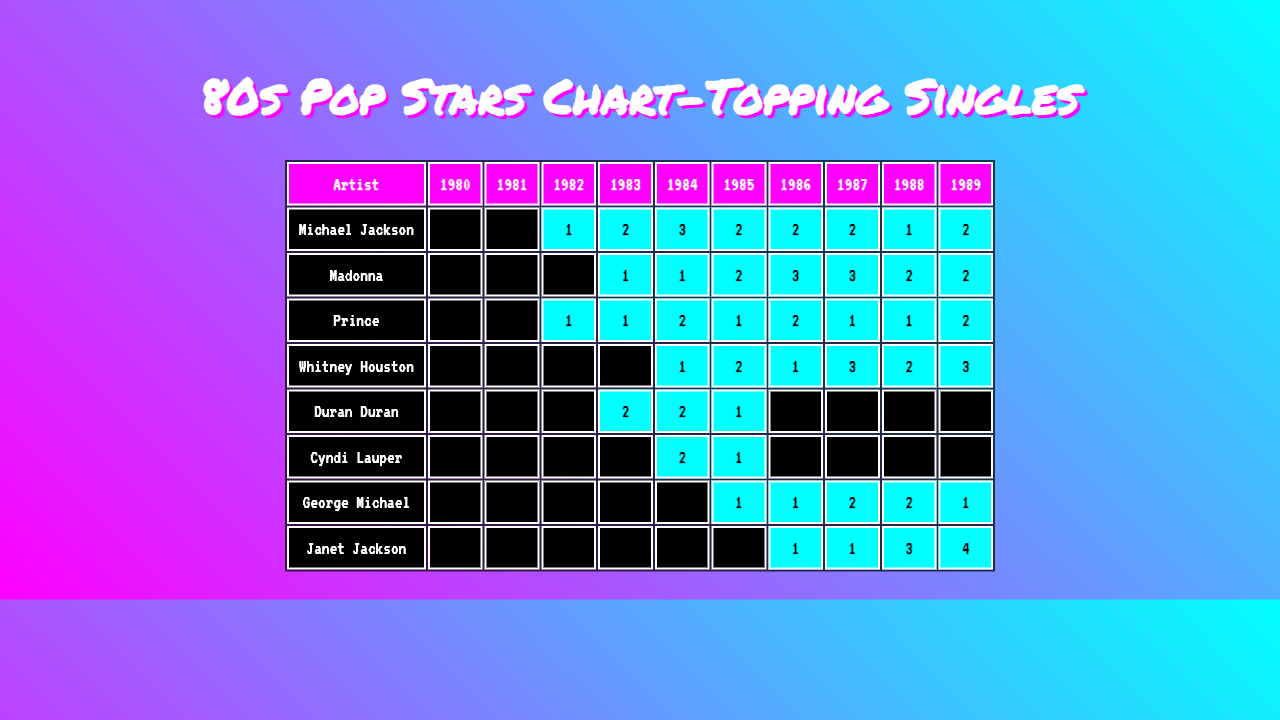What artist had the most chart-topping singles in 1984? Looking at the column for the year 1984, Michael Jackson has 3 chart-topping singles, which is the highest number among all artists for that year.
Answer: Michael Jackson How many chart-topping singles did Prince have in total during the 80s? Adding up Prince's singles from all years: 1 + 1 + 2 + 1 + 1 + 2 = 8.
Answer: 8 Did Whitney Houston reach the top of the charts in 1981? In the column for 1981, Whitney Houston has 0 chart-topping singles, indicating she did not reach the top that year.
Answer: No Which artist had the highest total of chart-topping singles in 1987, and how many did they have? Looking at the 1987 column, Janet Jackson has 1, Michael Jackson has 2, Whitney Houston has 3, and others have equal or fewer. Whitney Houston had the highest at 3.
Answer: Whitney Houston, 3 What is the average number of chart-topping singles per year for Cyndi Lauper over the decade? Summing Cyndi Lauper's singles: 0 + 0 + 0 + 0 + 2 + 1 + 0 + 0 + 0 = 3. Then, dividing by the number of years (10): 3 / 10 = 0.3.
Answer: 0.3 In which year did George Michael achieve the most chart-topping singles, and how many were there? Checking George Michael's row, he had 2 singles in both 1987 and 1988, which are the highest amounts for his row.
Answer: 1987 and 1988, 2 singles What was the trend of Duran Duran’s chart-topping singles throughout the 80s? Analyzing the numbers: 0, 0, 0, 2, 2, 1, 0, 0, 0, 0 shows they peaked in 1983 and 1984 with 2 each, but then decreased to 0 again afterward.
Answer: Peaked in 1983 and 1984, then decreased to 0 Which artist had a steady increase in chart-topping singles from 1982 to 1986? Examining the years for each artist, George Michael had 0 in 1982, 1 in 1985, and 2 in 1986. This shows an increase year by year.
Answer: George Michael How many artists had chart-topping singles in 1985, and who were they? In 1985, looking at the table, Michael Jackson (2), Madonna (2), Whitney Houston (2), and Cyndi Lauper (1) had singles. Four artists made the charts that year.
Answer: Four artists: Michael Jackson, Madonna, Whitney Houston, Cyndi Lauper What is the difference in chart-topping singles between Michael Jackson and Janet Jackson in 1988? For 1988, Michael Jackson had 1 and Janet Jackson had 3. The difference is 3 - 1 = 2.
Answer: 2 